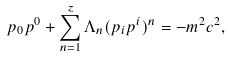<formula> <loc_0><loc_0><loc_500><loc_500>p _ { 0 } p ^ { 0 } + \sum _ { n = 1 } ^ { z } \Lambda _ { n } ( p _ { i } p ^ { i } ) ^ { n } = - m ^ { 2 } c ^ { 2 } ,</formula> 